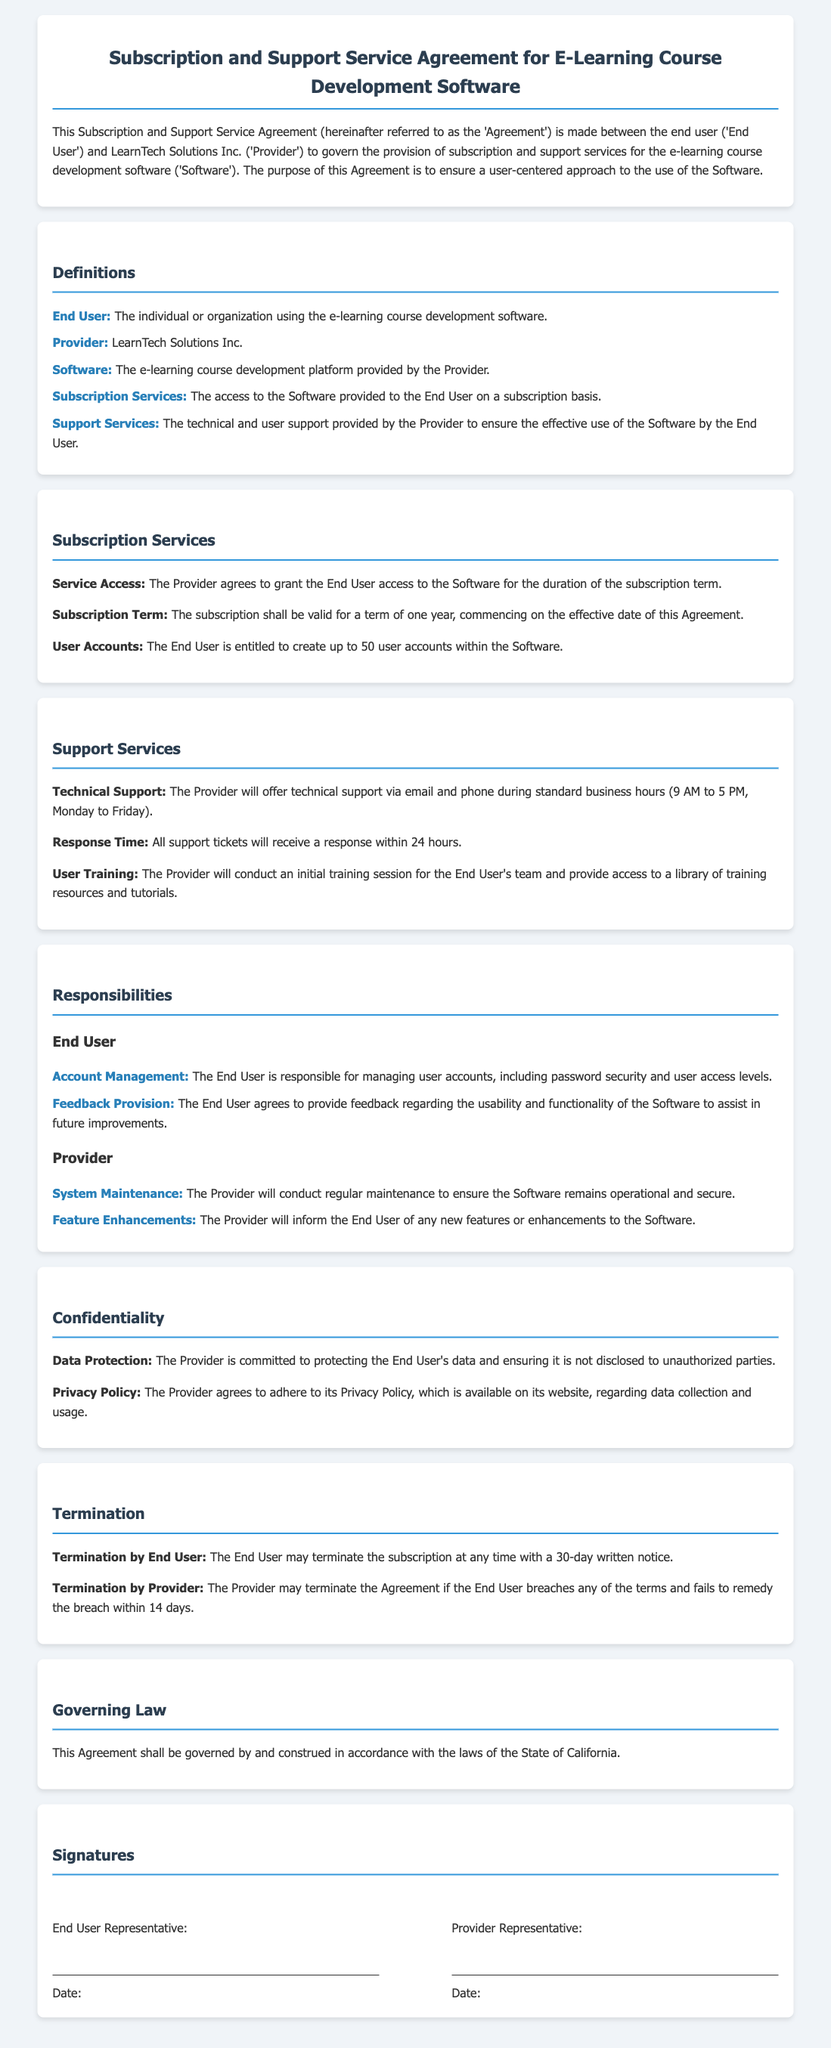What is the name of the Provider? The Provider is referred to as LearnTech Solutions Inc. in the document.
Answer: LearnTech Solutions Inc What is the subscription term duration? The subscription is valid for a term of one year, commencing on the effective date of the Agreement.
Answer: One year How many user accounts can the End User create? The End User is entitled to create up to 50 user accounts within the Software.
Answer: 50 user accounts What is the response time for support tickets? All support tickets will receive a response within 24 hours, as stated in the document.
Answer: 24 hours What does the End User have to provide to assist in Software improvements? The End User agrees to provide feedback regarding the usability and functionality of the Software.
Answer: Feedback What must the End User do to terminate the subscription? The End User may terminate the subscription at any time with a 30-day written notice.
Answer: 30-day written notice What is the governing law of the Agreement? The Agreement is governed by the laws of the State of California.
Answer: State of California During what hours is technical support available? The Provider will offer technical support during standard business hours, which are specified as 9 AM to 5 PM, Monday to Friday.
Answer: 9 AM to 5 PM, Monday to Friday 